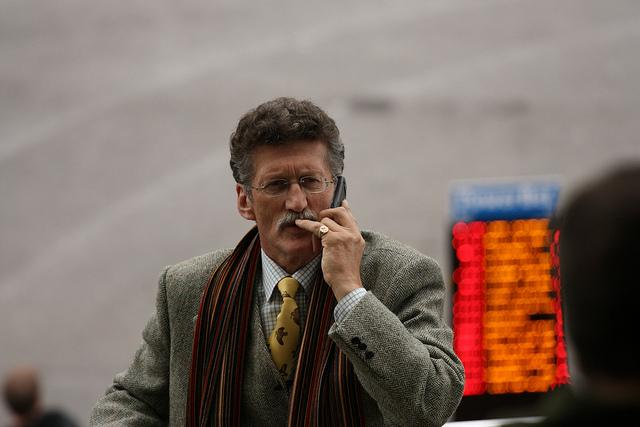What is the man with the mustache doing with the black object?

Choices:
A) gaming
B) paying
C) exercising
D) calling calling 